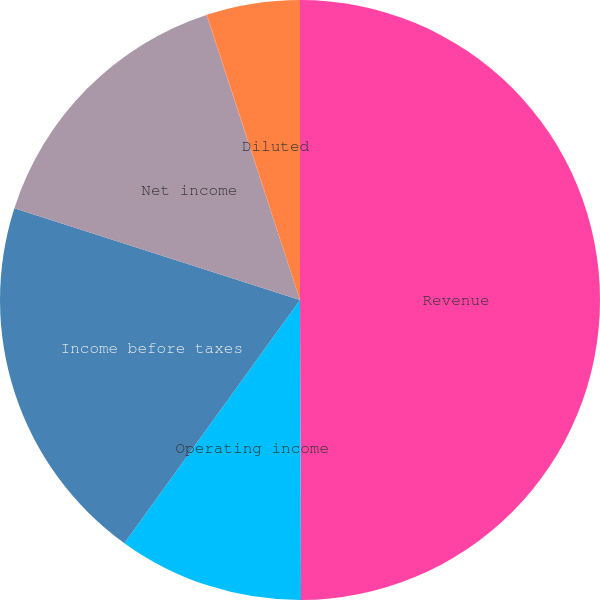<chart> <loc_0><loc_0><loc_500><loc_500><pie_chart><fcel>Revenue<fcel>Operating income<fcel>Income before taxes<fcel>Net income<fcel>Basic<fcel>Diluted<nl><fcel>49.94%<fcel>10.01%<fcel>19.99%<fcel>15.0%<fcel>0.03%<fcel>5.02%<nl></chart> 